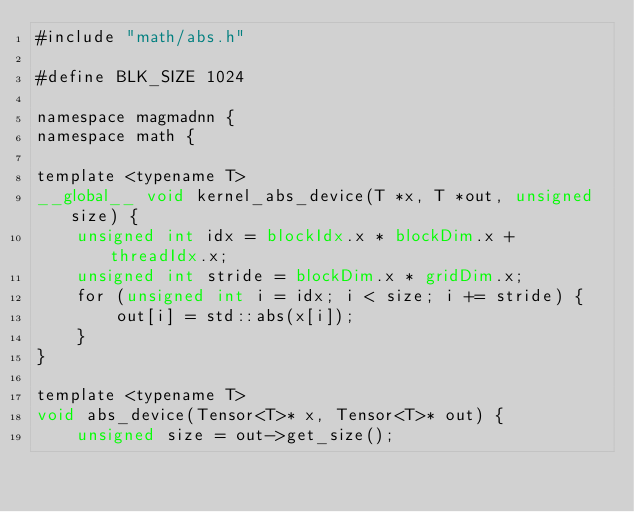Convert code to text. <code><loc_0><loc_0><loc_500><loc_500><_Cuda_>#include "math/abs.h"

#define BLK_SIZE 1024

namespace magmadnn {
namespace math {

template <typename T>
__global__ void kernel_abs_device(T *x, T *out, unsigned size) {
    unsigned int idx = blockIdx.x * blockDim.x + threadIdx.x;
    unsigned int stride = blockDim.x * gridDim.x;
    for (unsigned int i = idx; i < size; i += stride) {
        out[i] = std::abs(x[i]);
    }
}

template <typename T>
void abs_device(Tensor<T>* x, Tensor<T>* out) {
    unsigned size = out->get_size();</code> 